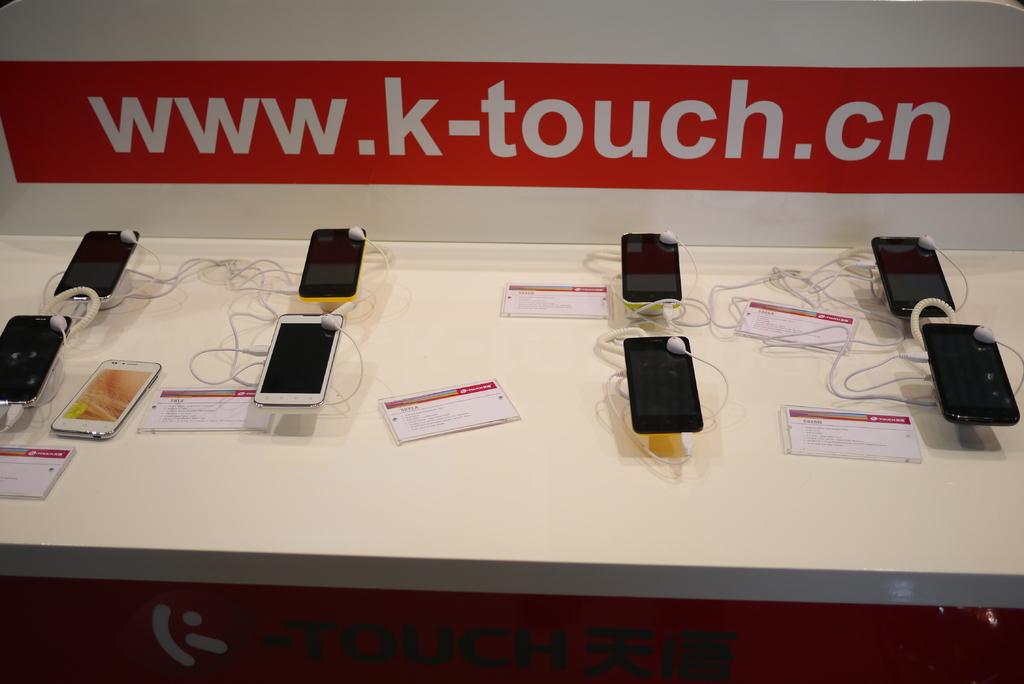What is the website?
Your answer should be compact. Www.k-touch.cn. What is the web-site address?
Provide a short and direct response. Www.k-touch.cn. 